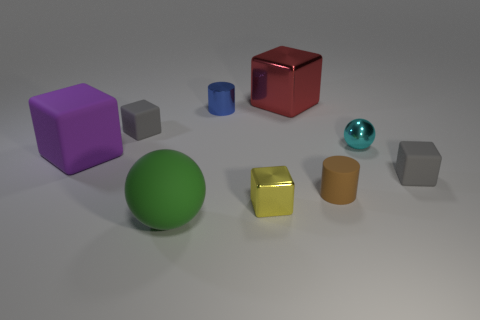Subtract all purple blocks. How many blocks are left? 4 Subtract all big purple rubber blocks. How many blocks are left? 4 Subtract all brown blocks. Subtract all yellow spheres. How many blocks are left? 5 Subtract all spheres. How many objects are left? 7 Subtract all big gray matte spheres. Subtract all green balls. How many objects are left? 8 Add 1 small shiny things. How many small shiny things are left? 4 Add 1 gray metallic blocks. How many gray metallic blocks exist? 1 Subtract 0 cyan cylinders. How many objects are left? 9 